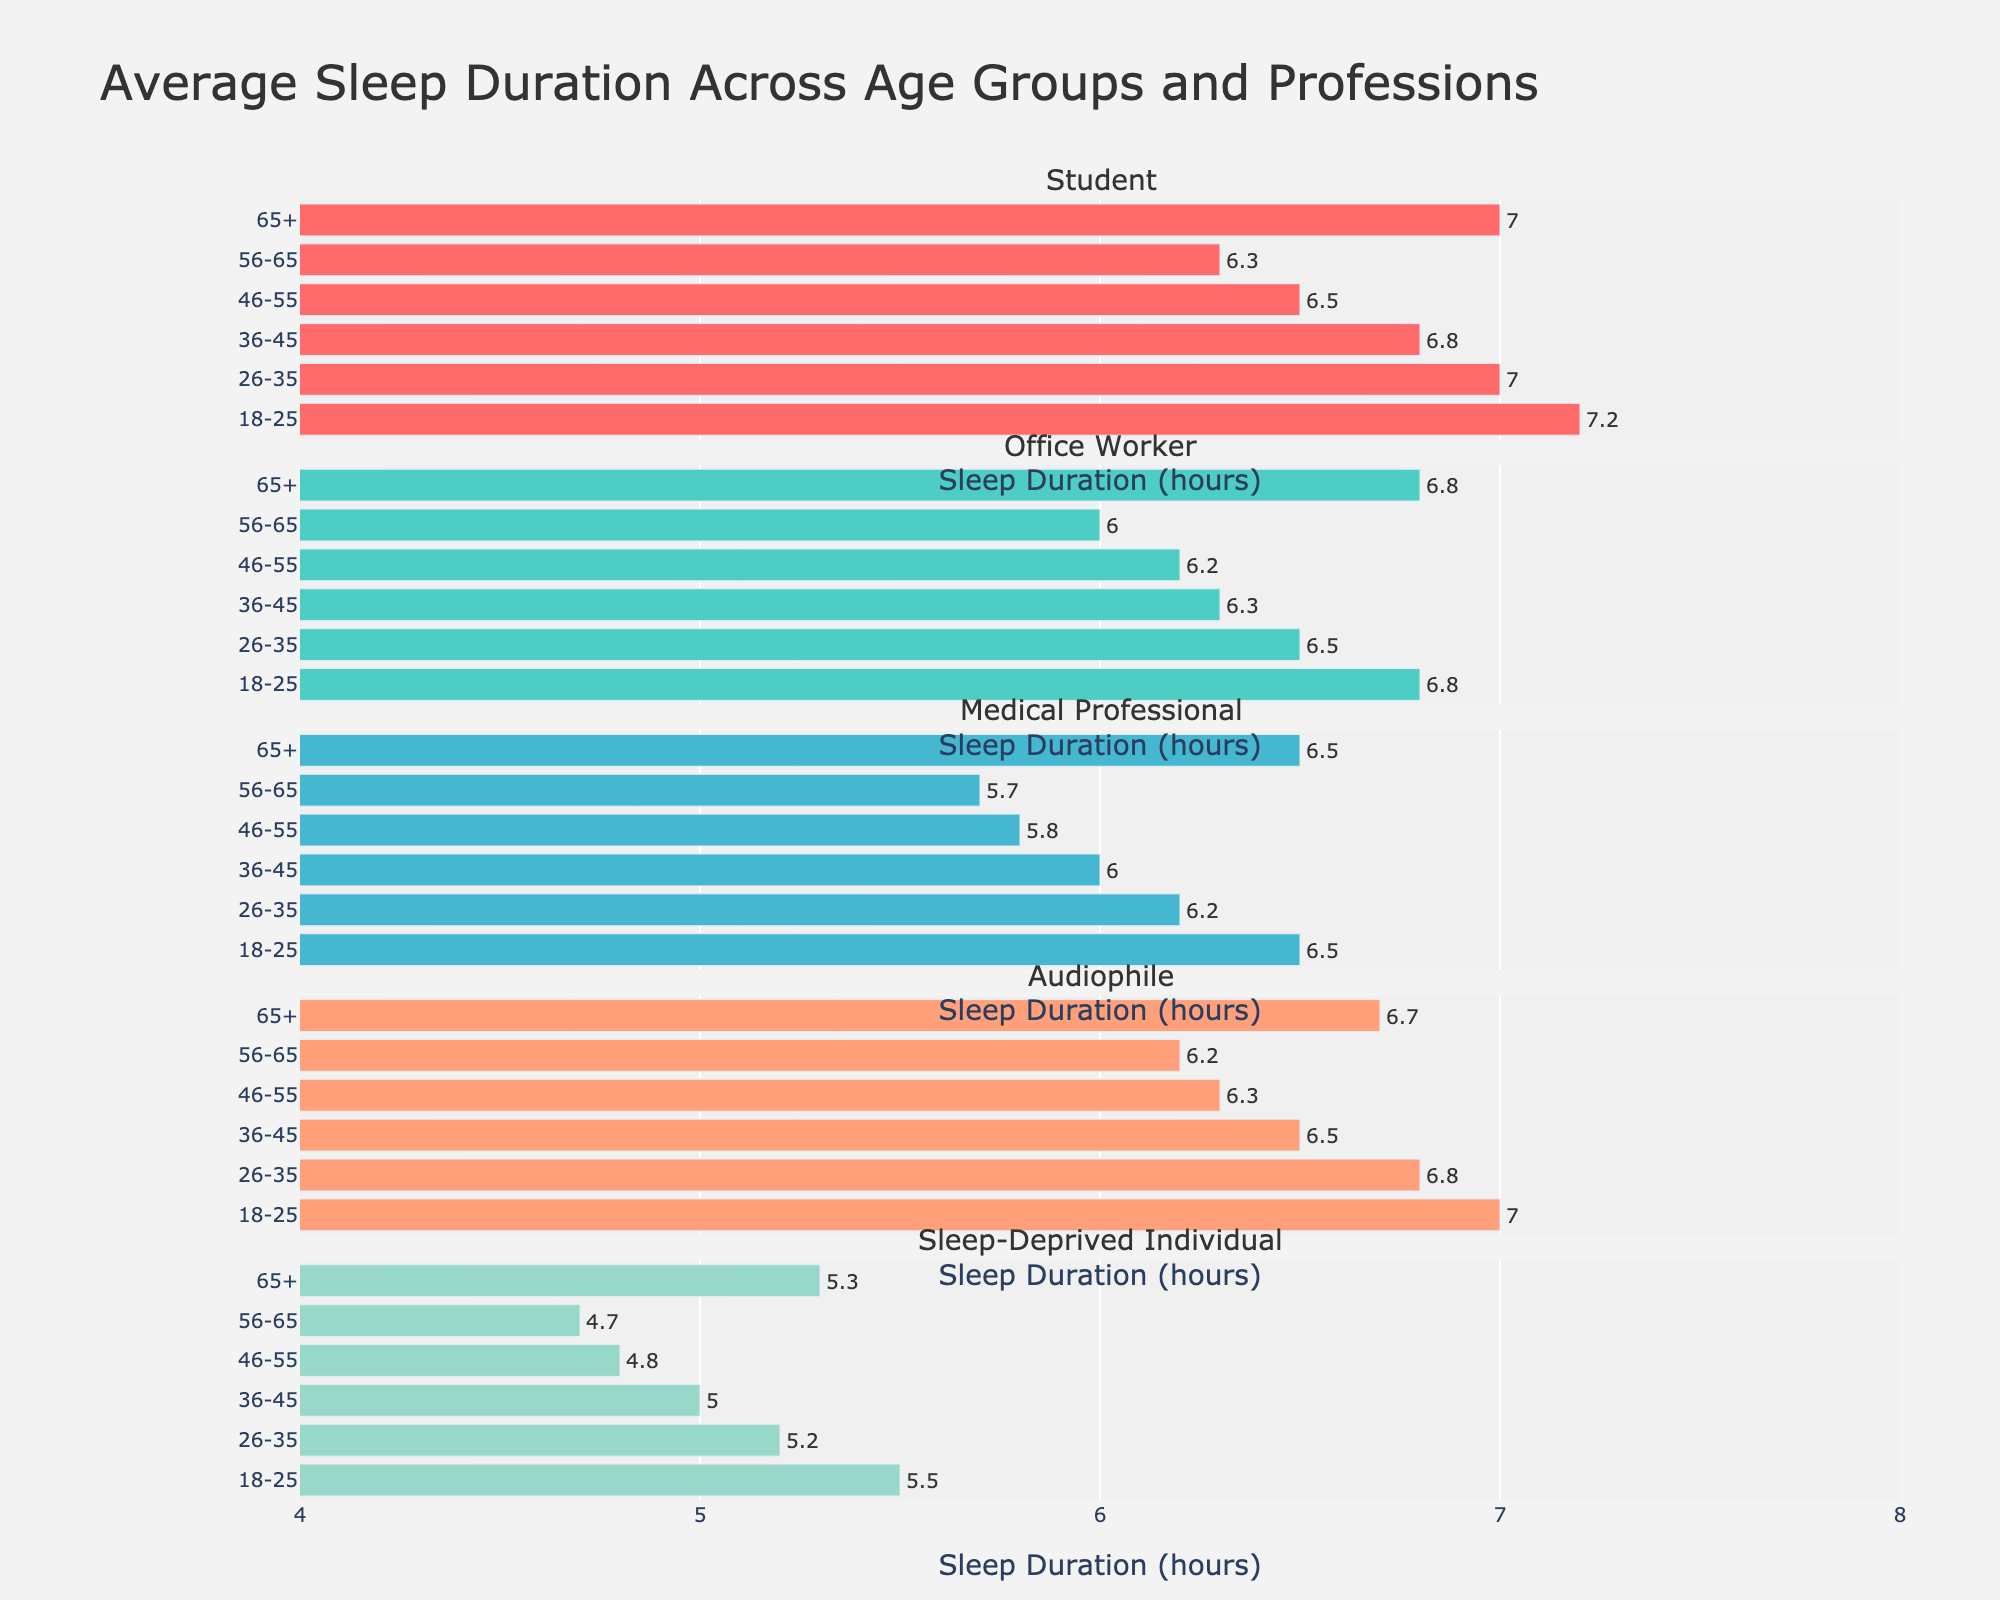What's the title of the figure? The title can be found at the top of the figure which gives an overview of what the figure represents.
Answer: Average Sleep Duration Across Age Groups and Professions What is the sleep duration for Medical Professionals in the 36-45 age group? Locate the "Medical Professional" subplot and look at the bar corresponding to the "36-45" age group.
Answer: 6.0 hours Which profession shows the highest average sleep duration in the 18-25 age group? Compare the bars across all subplots for the 18-25 age group. The tallest bar represents the profession with the highest sleep duration.
Answer: Student How does the sleep duration of an Audiophile aged 26-35 compare to that of a Sleep-Deprived Individual of the same age group? Locate the Audiophile and Sleep-Deprived Individual subplots. Compare the height of the bars for the 26-35 age group.
Answer: Audiophile: 6.8 hours, Sleep-Deprived Individual: 5.2 hours What is the difference in sleep duration between Office Workers and Sleep-Deprived Individuals in the 56-65 age group? Find the sleep durations for Office Workers and Sleep-Deprived Individuals in the 56-65 age group. Subtract the duration of Sleep-Deprived Individuals from that of Office Workers.
Answer: 6.0 - 4.7 = 1.3 hours Which age group has the lowest average sleep duration overall? For each age group, find the minimum average sleep duration across all professions. Identify the age group with the lowest value.
Answer: 46-55 Among the professions listed, which one experiences the least variance in sleep duration across all age groups? Calculate the range of sleep durations for each profession by subtracting the minimum sleep duration from the maximum. Compare these ranges to find the smallest one.
Answer: Medical Professional Does the pattern of sleep duration for Audiophiles show a significant increase or decrease with age? Observe the trend in the bars for Audiophiles across different age groups to identify any significant increases or decreases.
Answer: Slight decrease, then slight increase How much more sleep do Students in the 18-25 age group get compared to Students in the 56-65 age group? Find the sleep durations for Students in the 18-25 and 56-65 age groups. Subtract the latter from the former.
Answer: 7.2 - 6.3 = 0.9 hours What's the average sleep duration for Sleep-Deprived Individuals across all age groups? Sum the sleep durations for Sleep-Deprived Individuals across all age groups and divide by the number of age groups.
Answer: (5.5 + 5.2 + 5.0 + 4.8 + 4.7 + 5.3) / 6 ≈ 5.08 hours 